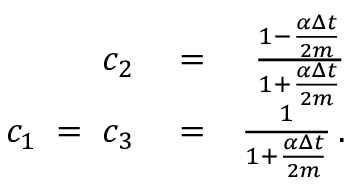Convert formula to latex. <formula><loc_0><loc_0><loc_500><loc_500>\begin{array} { r l r } { c _ { 2 } } & = } & { \frac { 1 - \frac { \alpha \Delta { t } } { 2 m } } { 1 + \frac { \alpha \Delta { t } } { 2 m } } } \\ { c _ { 1 } \, = \, c _ { 3 } } & = } & { \frac { 1 } { 1 + \frac { \alpha \Delta { t } } { 2 m } } \, . } \end{array}</formula> 